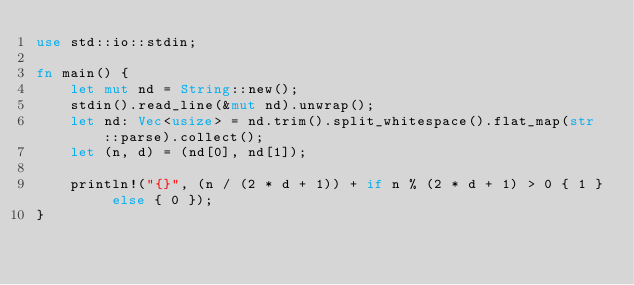<code> <loc_0><loc_0><loc_500><loc_500><_Rust_>use std::io::stdin;

fn main() {
    let mut nd = String::new();
    stdin().read_line(&mut nd).unwrap();
    let nd: Vec<usize> = nd.trim().split_whitespace().flat_map(str::parse).collect();
    let (n, d) = (nd[0], nd[1]);

    println!("{}", (n / (2 * d + 1)) + if n % (2 * d + 1) > 0 { 1 } else { 0 });
}
</code> 